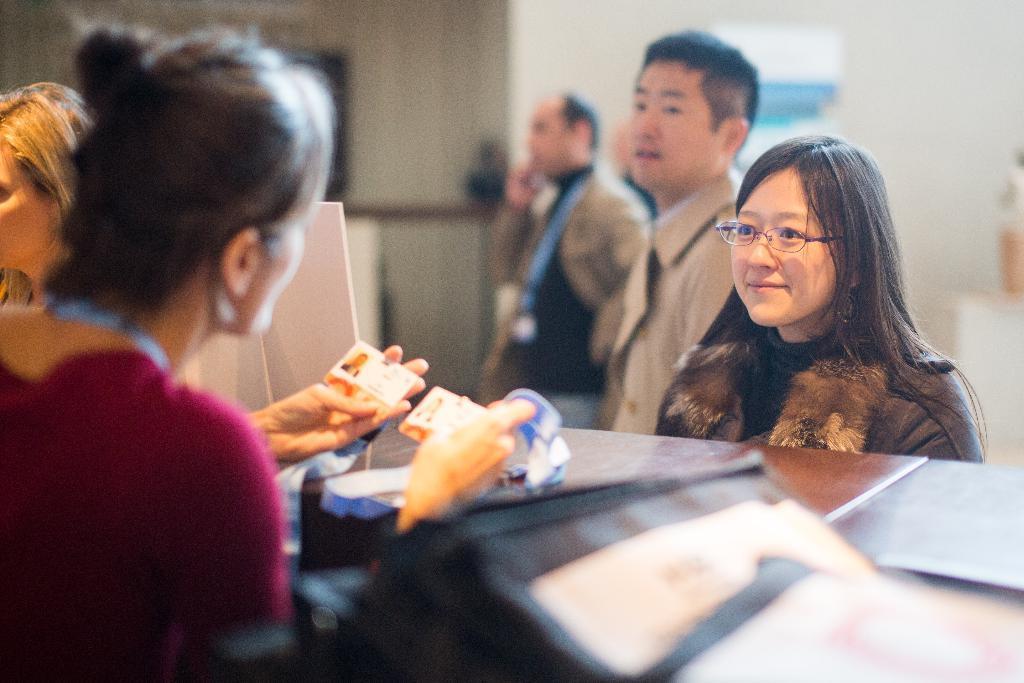Could you give a brief overview of what you see in this image? Here we can see few persons. A person is holding cards with her hands. There are tables. In the background we can see wall. 